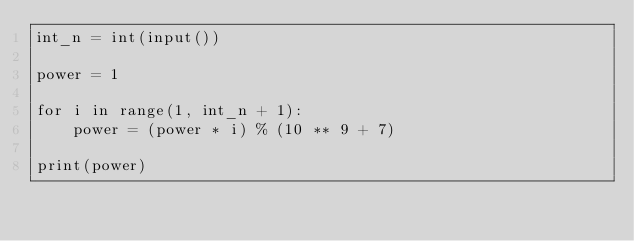Convert code to text. <code><loc_0><loc_0><loc_500><loc_500><_Python_>int_n = int(input())

power = 1

for i in range(1, int_n + 1):
    power = (power * i) % (10 ** 9 + 7)

print(power)</code> 